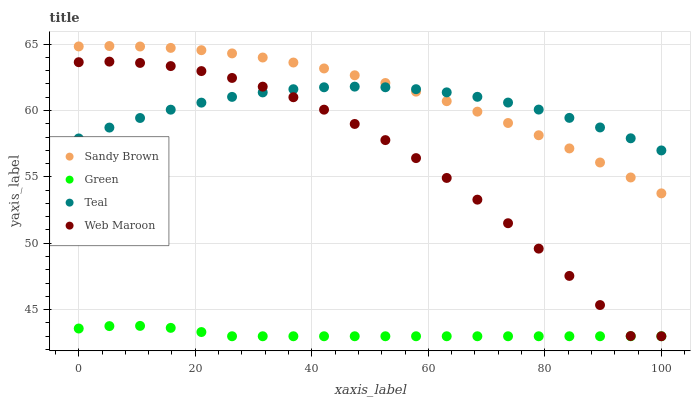Does Green have the minimum area under the curve?
Answer yes or no. Yes. Does Sandy Brown have the maximum area under the curve?
Answer yes or no. Yes. Does Sandy Brown have the minimum area under the curve?
Answer yes or no. No. Does Green have the maximum area under the curve?
Answer yes or no. No. Is Green the smoothest?
Answer yes or no. Yes. Is Web Maroon the roughest?
Answer yes or no. Yes. Is Sandy Brown the smoothest?
Answer yes or no. No. Is Sandy Brown the roughest?
Answer yes or no. No. Does Web Maroon have the lowest value?
Answer yes or no. Yes. Does Sandy Brown have the lowest value?
Answer yes or no. No. Does Sandy Brown have the highest value?
Answer yes or no. Yes. Does Green have the highest value?
Answer yes or no. No. Is Green less than Teal?
Answer yes or no. Yes. Is Sandy Brown greater than Web Maroon?
Answer yes or no. Yes. Does Teal intersect Web Maroon?
Answer yes or no. Yes. Is Teal less than Web Maroon?
Answer yes or no. No. Is Teal greater than Web Maroon?
Answer yes or no. No. Does Green intersect Teal?
Answer yes or no. No. 